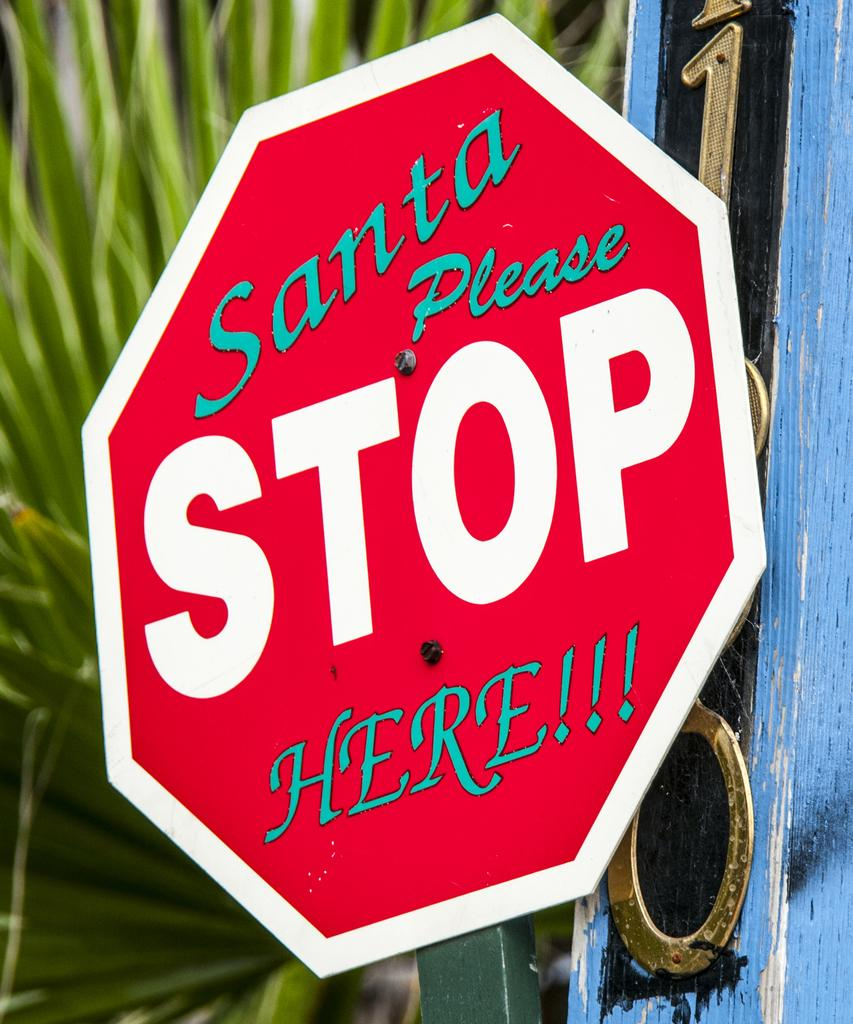<image>
Offer a succinct explanation of the picture presented. a stop sign that has an octagon shape and other writing 